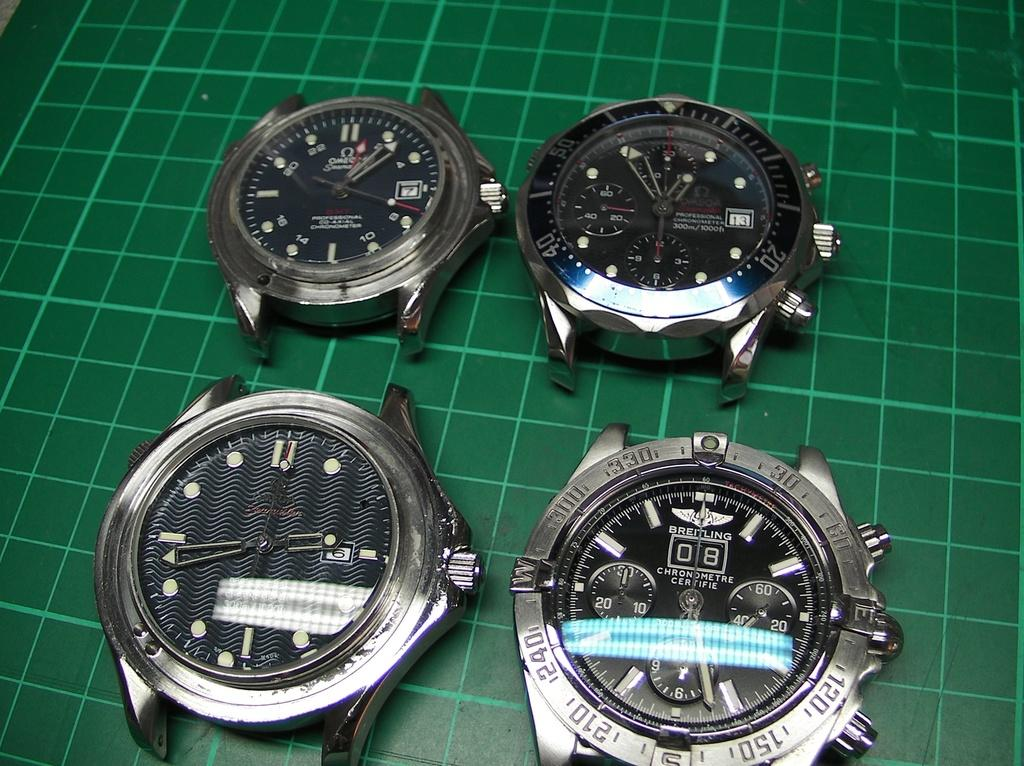Provide a one-sentence caption for the provided image. four different watches one with the number 8 on it. 